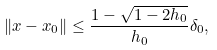Convert formula to latex. <formula><loc_0><loc_0><loc_500><loc_500>\left \| x - x _ { 0 } \right \| \leq \frac { 1 - \sqrt { 1 - 2 h _ { 0 } } } { h _ { 0 } } \delta _ { 0 } ,</formula> 